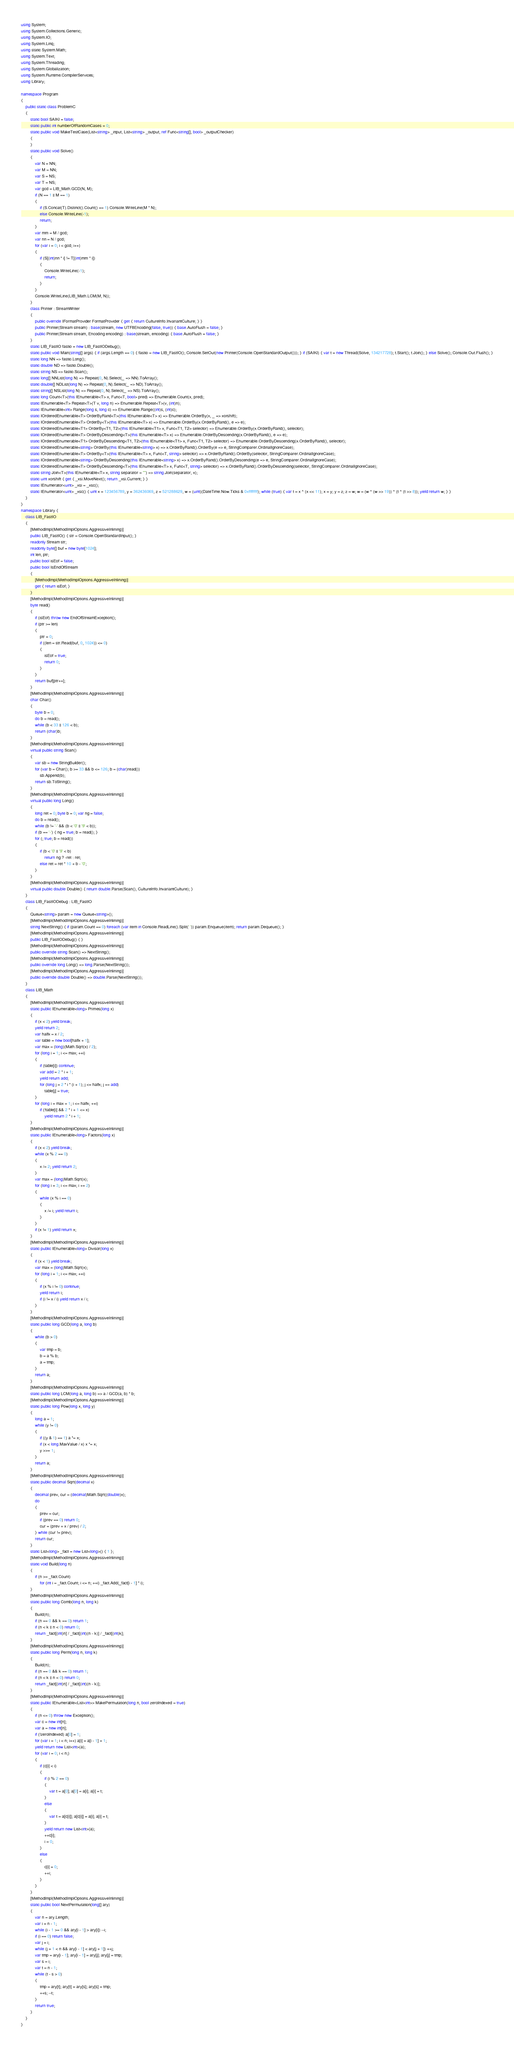<code> <loc_0><loc_0><loc_500><loc_500><_C#_>using System;
using System.Collections.Generic;
using System.IO;
using System.Linq;
using static System.Math;
using System.Text;
using System.Threading;
using System.Globalization;
using System.Runtime.CompilerServices;
using Library;

namespace Program
{
    public static class ProblemC
    {
        static bool SAIKI = false;
        static public int numberOfRandomCases = 0;
        static public void MakeTestCase(List<string> _input, List<string> _output, ref Func<string[], bool> _outputChecker)
        {
        }
        static public void Solve()
        {
            var N = NN;
            var M = NN;
            var S = NS;
            var T = NS;
            var gcd = LIB_Math.GCD(N, M);
            if (N == 1 || M == 1)
            {
                if (S.Concat(T).Distinct().Count() == 1) Console.WriteLine(M * N);
                else Console.WriteLine(-1);
                return;
            }
            var mm = M / gcd;
            var nn = N / gcd;
            for (var i = 0; i < gcd; i++)
            {
                if (S[(int)nn * i] != T[(int)mm * i])
                {
                    Console.WriteLine(-1);
                    return;
                }
            }
            Console.WriteLine(LIB_Math.LCM(M, N));
        }
        class Printer : StreamWriter
        {
            public override IFormatProvider FormatProvider { get { return CultureInfo.InvariantCulture; } }
            public Printer(Stream stream) : base(stream, new UTF8Encoding(false, true)) { base.AutoFlush = false; }
            public Printer(Stream stream, Encoding encoding) : base(stream, encoding) { base.AutoFlush = false; }
        }
        static LIB_FastIO fastio = new LIB_FastIODebug();
        static public void Main(string[] args) { if (args.Length == 0) { fastio = new LIB_FastIO(); Console.SetOut(new Printer(Console.OpenStandardOutput())); } if (SAIKI) { var t = new Thread(Solve, 134217728); t.Start(); t.Join(); } else Solve(); Console.Out.Flush(); }
        static long NN => fastio.Long();
        static double ND => fastio.Double();
        static string NS => fastio.Scan();
        static long[] NNList(long N) => Repeat(0, N).Select(_ => NN).ToArray();
        static double[] NDList(long N) => Repeat(0, N).Select(_ => ND).ToArray();
        static string[] NSList(long N) => Repeat(0, N).Select(_ => NS).ToArray();
        static long Count<T>(this IEnumerable<T> x, Func<T, bool> pred) => Enumerable.Count(x, pred);
        static IEnumerable<T> Repeat<T>(T v, long n) => Enumerable.Repeat<T>(v, (int)n);
        static IEnumerable<int> Range(long s, long c) => Enumerable.Range((int)s, (int)c);
        static IOrderedEnumerable<T> OrderByRand<T>(this IEnumerable<T> x) => Enumerable.OrderBy(x, _ => xorshift);
        static IOrderedEnumerable<T> OrderBy<T>(this IEnumerable<T> x) => Enumerable.OrderBy(x.OrderByRand(), e => e);
        static IOrderedEnumerable<T1> OrderBy<T1, T2>(this IEnumerable<T1> x, Func<T1, T2> selector) => Enumerable.OrderBy(x.OrderByRand(), selector);
        static IOrderedEnumerable<T> OrderByDescending<T>(this IEnumerable<T> x) => Enumerable.OrderByDescending(x.OrderByRand(), e => e);
        static IOrderedEnumerable<T1> OrderByDescending<T1, T2>(this IEnumerable<T1> x, Func<T1, T2> selector) => Enumerable.OrderByDescending(x.OrderByRand(), selector);
        static IOrderedEnumerable<string> OrderBy(this IEnumerable<string> x) => x.OrderByRand().OrderBy(e => e, StringComparer.OrdinalIgnoreCase);
        static IOrderedEnumerable<T> OrderBy<T>(this IEnumerable<T> x, Func<T, string> selector) => x.OrderByRand().OrderBy(selector, StringComparer.OrdinalIgnoreCase);
        static IOrderedEnumerable<string> OrderByDescending(this IEnumerable<string> x) => x.OrderByRand().OrderByDescending(e => e, StringComparer.OrdinalIgnoreCase);
        static IOrderedEnumerable<T> OrderByDescending<T>(this IEnumerable<T> x, Func<T, string> selector) => x.OrderByRand().OrderByDescending(selector, StringComparer.OrdinalIgnoreCase);
        static string Join<T>(this IEnumerable<T> x, string separator = "") => string.Join(separator, x);
        static uint xorshift { get { _xsi.MoveNext(); return _xsi.Current; } }
        static IEnumerator<uint> _xsi = _xsc();
        static IEnumerator<uint> _xsc() { uint x = 123456789, y = 362436069, z = 521288629, w = (uint)(DateTime.Now.Ticks & 0xffffffff); while (true) { var t = x ^ (x << 11); x = y; y = z; z = w; w = (w ^ (w >> 19)) ^ (t ^ (t >> 8)); yield return w; } }
    }
}
namespace Library {
    class LIB_FastIO
    {
        [MethodImpl(MethodImplOptions.AggressiveInlining)]
        public LIB_FastIO() { str = Console.OpenStandardInput(); }
        readonly Stream str;
        readonly byte[] buf = new byte[1024];
        int len, ptr;
        public bool isEof = false;
        public bool IsEndOfStream
        {
            [MethodImpl(MethodImplOptions.AggressiveInlining)]
            get { return isEof; }
        }
        [MethodImpl(MethodImplOptions.AggressiveInlining)]
        byte read()
        {
            if (isEof) throw new EndOfStreamException();
            if (ptr >= len)
            {
                ptr = 0;
                if ((len = str.Read(buf, 0, 1024)) <= 0)
                {
                    isEof = true;
                    return 0;
                }
            }
            return buf[ptr++];
        }
        [MethodImpl(MethodImplOptions.AggressiveInlining)]
        char Char()
        {
            byte b = 0;
            do b = read();
            while (b < 33 || 126 < b);
            return (char)b;
        }
        [MethodImpl(MethodImplOptions.AggressiveInlining)]
        virtual public string Scan()
        {
            var sb = new StringBuilder();
            for (var b = Char(); b >= 33 && b <= 126; b = (char)read())
                sb.Append(b);
            return sb.ToString();
        }
        [MethodImpl(MethodImplOptions.AggressiveInlining)]
        virtual public long Long()
        {
            long ret = 0; byte b = 0; var ng = false;
            do b = read();
            while (b != '-' && (b < '0' || '9' < b));
            if (b == '-') { ng = true; b = read(); }
            for (; true; b = read())
            {
                if (b < '0' || '9' < b)
                    return ng ? -ret : ret;
                else ret = ret * 10 + b - '0';
            }
        }
        [MethodImpl(MethodImplOptions.AggressiveInlining)]
        virtual public double Double() { return double.Parse(Scan(), CultureInfo.InvariantCulture); }
    }
    class LIB_FastIODebug : LIB_FastIO
    {
        Queue<string> param = new Queue<string>();
        [MethodImpl(MethodImplOptions.AggressiveInlining)]
        string NextString() { if (param.Count == 0) foreach (var item in Console.ReadLine().Split(' ')) param.Enqueue(item); return param.Dequeue(); }
        [MethodImpl(MethodImplOptions.AggressiveInlining)]
        public LIB_FastIODebug() { }
        [MethodImpl(MethodImplOptions.AggressiveInlining)]
        public override string Scan() => NextString();
        [MethodImpl(MethodImplOptions.AggressiveInlining)]
        public override long Long() => long.Parse(NextString());
        [MethodImpl(MethodImplOptions.AggressiveInlining)]
        public override double Double() => double.Parse(NextString());
    }
    class LIB_Math
    {
        [MethodImpl(MethodImplOptions.AggressiveInlining)]
        static public IEnumerable<long> Primes(long x)
        {
            if (x < 2) yield break;
            yield return 2;
            var halfx = x / 2;
            var table = new bool[halfx + 1];
            var max = (long)(Math.Sqrt(x) / 2);
            for (long i = 1; i <= max; ++i)
            {
                if (table[i]) continue;
                var add = 2 * i + 1;
                yield return add;
                for (long j = 2 * i * (i + 1); j <= halfx; j += add)
                    table[j] = true;
            }
            for (long i = max + 1; i <= halfx; ++i)
                if (!table[i] && 2 * i + 1 <= x)
                    yield return 2 * i + 1;
        }
        [MethodImpl(MethodImplOptions.AggressiveInlining)]
        static public IEnumerable<long> Factors(long x)
        {
            if (x < 2) yield break;
            while (x % 2 == 0)
            {
                x /= 2; yield return 2;
            }
            var max = (long)Math.Sqrt(x);
            for (long i = 3; i <= max; i += 2)
            {
                while (x % i == 0)
                {
                    x /= i; yield return i;
                }
            }
            if (x != 1) yield return x;
        }
        [MethodImpl(MethodImplOptions.AggressiveInlining)]
        static public IEnumerable<long> Divisor(long x)
        {
            if (x < 1) yield break;
            var max = (long)Math.Sqrt(x);
            for (long i = 1; i <= max; ++i)
            {
                if (x % i != 0) continue;
                yield return i;
                if (i != x / i) yield return x / i;
            }
        }
        [MethodImpl(MethodImplOptions.AggressiveInlining)]
        static public long GCD(long a, long b)
        {
            while (b > 0)
            {
                var tmp = b;
                b = a % b;
                a = tmp;
            }
            return a;
        }
        [MethodImpl(MethodImplOptions.AggressiveInlining)]
        static public long LCM(long a, long b) => a / GCD(a, b) * b;
        [MethodImpl(MethodImplOptions.AggressiveInlining)]
        static public long Pow(long x, long y)
        {
            long a = 1;
            while (y != 0)
            {
                if ((y & 1) == 1) a *= x;
                if (x < long.MaxValue / x) x *= x;
                y >>= 1;
            }
            return a;
        }
        [MethodImpl(MethodImplOptions.AggressiveInlining)]
        static public decimal Sqrt(decimal x)
        {
            decimal prev, cur = (decimal)Math.Sqrt((double)x);
            do
            {
                prev = cur;
                if (prev == 0) return 0;
                cur = (prev + x / prev) / 2;
            } while (cur != prev);
            return cur;
        }
        static List<long> _fact = new List<long>() { 1 };
        [MethodImpl(MethodImplOptions.AggressiveInlining)]
        static void Build(long n)
        {
            if (n >= _fact.Count)
                for (int i = _fact.Count; i <= n; ++i) _fact.Add(_fact[i - 1] * i);
        }
        [MethodImpl(MethodImplOptions.AggressiveInlining)]
        static public long Comb(long n, long k)
        {
            Build(n);
            if (n == 0 && k == 0) return 1;
            if (n < k || n < 0) return 0;
            return _fact[(int)n] / _fact[(int)(n - k)] / _fact[(int)k];
        }
        [MethodImpl(MethodImplOptions.AggressiveInlining)]
        static public long Perm(long n, long k)
        {
            Build(n);
            if (n == 0 && k == 0) return 1;
            if (n < k || n < 0) return 0;
            return _fact[(int)n] / _fact[(int)(n - k)];
        }
        [MethodImpl(MethodImplOptions.AggressiveInlining)]
        static public IEnumerable<List<int>> MakePermutation(long n, bool zeroIndexed = true)
        {
            if (n <= 0) throw new Exception();
            var c = new int[n];
            var a = new int[n];
            if (!zeroIndexed) a[0] = 1;
            for (var i = 1; i < n; i++) a[i] = a[i - 1] + 1;
            yield return new List<int>(a);
            for (var i = 0; i < n;)
            {
                if (c[i] < i)
                {
                    if (i % 2 == 0)
                    {
                        var t = a[0]; a[0] = a[i]; a[i] = t;
                    }
                    else
                    {
                        var t = a[c[i]]; a[c[i]] = a[i]; a[i] = t;
                    }
                    yield return new List<int>(a);
                    ++c[i];
                    i = 0;
                }
                else
                {
                    c[i] = 0;
                    ++i;
                }
            }
        }
        [MethodImpl(MethodImplOptions.AggressiveInlining)]
        static public bool NextPermutation(long[] ary)
        {
            var n = ary.Length;
            var i = n - 1;
            while (i - 1 >= 0 && ary[i - 1] > ary[i]) --i;
            if (i == 0) return false;
            var j = i;
            while (j + 1 < n && ary[i - 1] < ary[j + 1]) ++j;
            var tmp = ary[i - 1]; ary[i - 1] = ary[j]; ary[j] = tmp;
            var s = i;
            var t = n - 1;
            while (t - s > 0)
            {
                tmp = ary[t]; ary[t] = ary[s]; ary[s] = tmp;
                ++s; --t;
            }
            return true;
        }
    }
}
</code> 